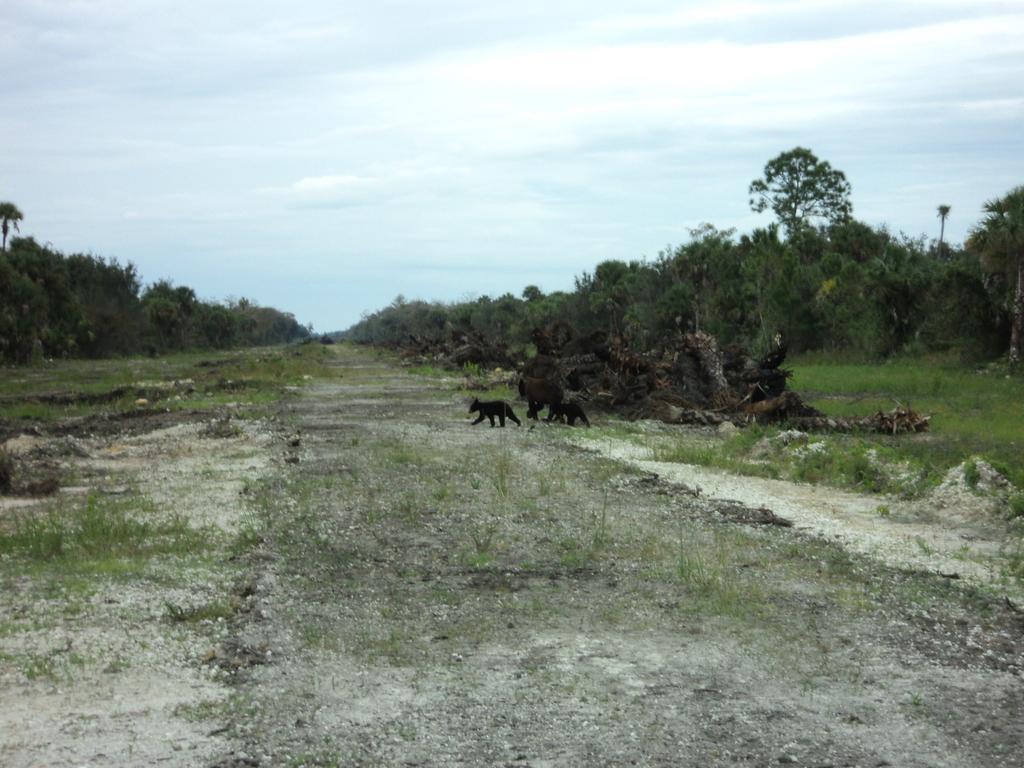Could you give a brief overview of what you see in this image? In the center of the image there are animals. On the right there are logs. In the background there are trees and sky. At the bottom there is grass. 